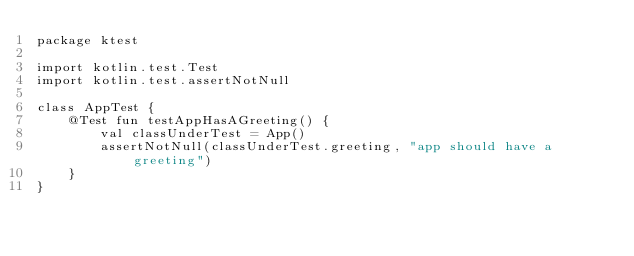Convert code to text. <code><loc_0><loc_0><loc_500><loc_500><_Kotlin_>package ktest

import kotlin.test.Test
import kotlin.test.assertNotNull

class AppTest {
    @Test fun testAppHasAGreeting() {
        val classUnderTest = App()
        assertNotNull(classUnderTest.greeting, "app should have a greeting")
    }
}
</code> 